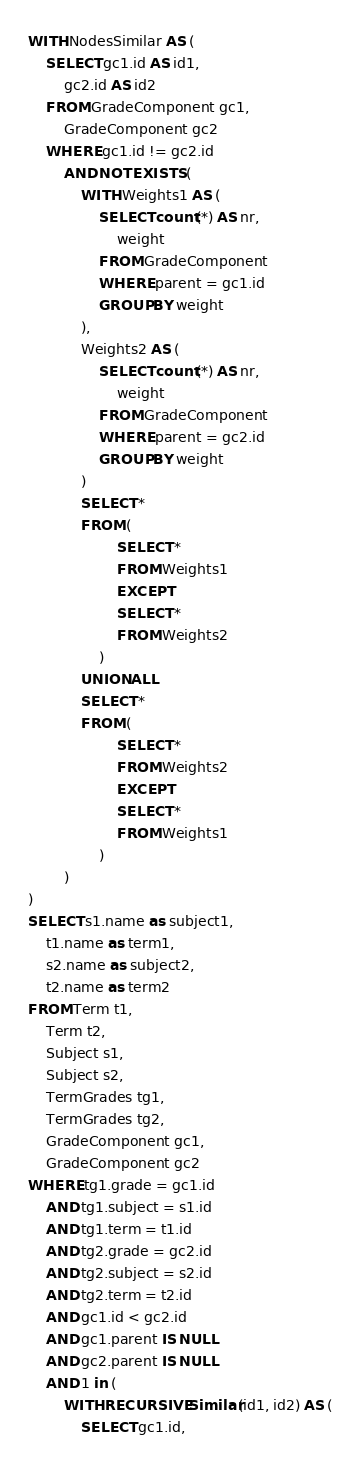Convert code to text. <code><loc_0><loc_0><loc_500><loc_500><_SQL_>WITH NodesSimilar AS (
    SELECT gc1.id AS id1,
        gc2.id AS id2
    FROM GradeComponent gc1,
        GradeComponent gc2
    WHERE gc1.id != gc2.id
        AND NOT EXISTS (
            WITH Weights1 AS (
                SELECT count(*) AS nr,
                    weight
                FROM GradeComponent
                WHERE parent = gc1.id
                GROUP BY weight
            ),
            Weights2 AS (
                SELECT count(*) AS nr,
                    weight
                FROM GradeComponent
                WHERE parent = gc2.id
                GROUP BY weight
            )
            SELECT *
            FROM (
                    SELECT *
                    FROM Weights1
                    EXCEPT
                    SELECT *
                    FROM Weights2
                )
            UNION ALL
            SELECT *
            FROM (
                    SELECT *
                    FROM Weights2
                    EXCEPT
                    SELECT *
                    FROM Weights1
                )
        )
)
SELECT s1.name as subject1,
    t1.name as term1,
    s2.name as subject2,
    t2.name as term2
FROM Term t1,
    Term t2,
    Subject s1,
    Subject s2,
    TermGrades tg1,
    TermGrades tg2,
    GradeComponent gc1,
    GradeComponent gc2
WHERE tg1.grade = gc1.id
    AND tg1.subject = s1.id
    AND tg1.term = t1.id
    AND tg2.grade = gc2.id
    AND tg2.subject = s2.id
    AND tg2.term = t2.id
    AND gc1.id < gc2.id
    AND gc1.parent IS NULL
    AND gc2.parent IS NULL
    AND 1 in (
        WITH RECURSIVE Similar(id1, id2) AS (
            SELECT gc1.id,</code> 